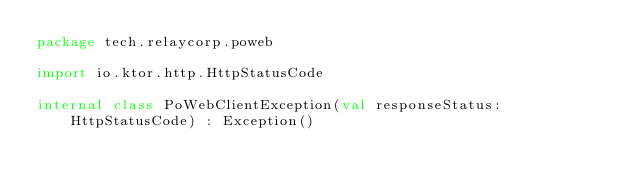<code> <loc_0><loc_0><loc_500><loc_500><_Kotlin_>package tech.relaycorp.poweb

import io.ktor.http.HttpStatusCode

internal class PoWebClientException(val responseStatus: HttpStatusCode) : Exception()
</code> 